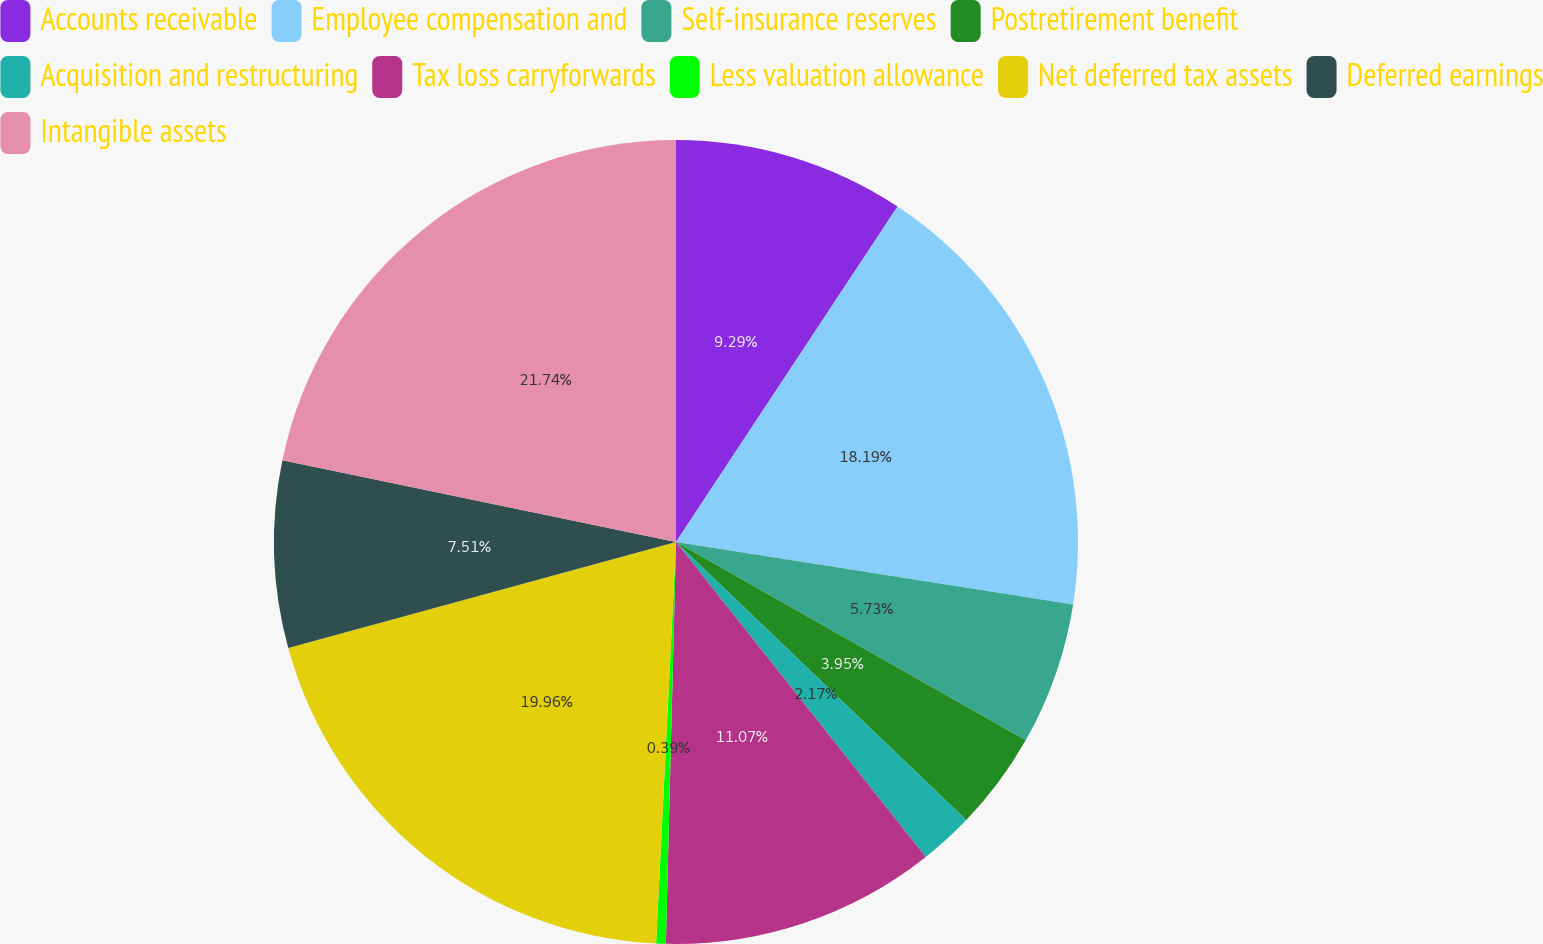Convert chart. <chart><loc_0><loc_0><loc_500><loc_500><pie_chart><fcel>Accounts receivable<fcel>Employee compensation and<fcel>Self-insurance reserves<fcel>Postretirement benefit<fcel>Acquisition and restructuring<fcel>Tax loss carryforwards<fcel>Less valuation allowance<fcel>Net deferred tax assets<fcel>Deferred earnings<fcel>Intangible assets<nl><fcel>9.29%<fcel>18.19%<fcel>5.73%<fcel>3.95%<fcel>2.17%<fcel>11.07%<fcel>0.39%<fcel>19.96%<fcel>7.51%<fcel>21.74%<nl></chart> 